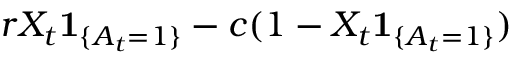Convert formula to latex. <formula><loc_0><loc_0><loc_500><loc_500>r X _ { t } 1 _ { \{ A _ { t } = 1 \} } - c ( 1 - X _ { t } 1 _ { \{ A _ { t } = 1 \} } )</formula> 